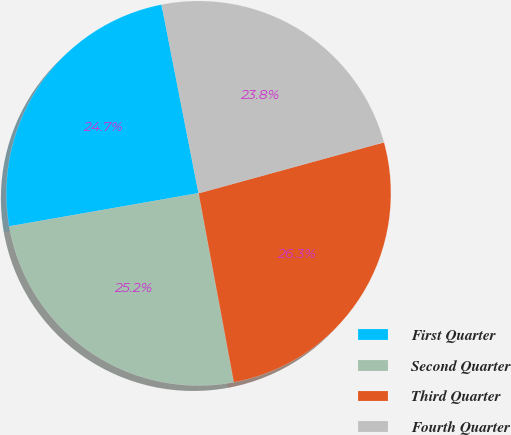Convert chart to OTSL. <chart><loc_0><loc_0><loc_500><loc_500><pie_chart><fcel>First Quarter<fcel>Second Quarter<fcel>Third Quarter<fcel>Fourth Quarter<nl><fcel>24.68%<fcel>25.17%<fcel>26.34%<fcel>23.81%<nl></chart> 